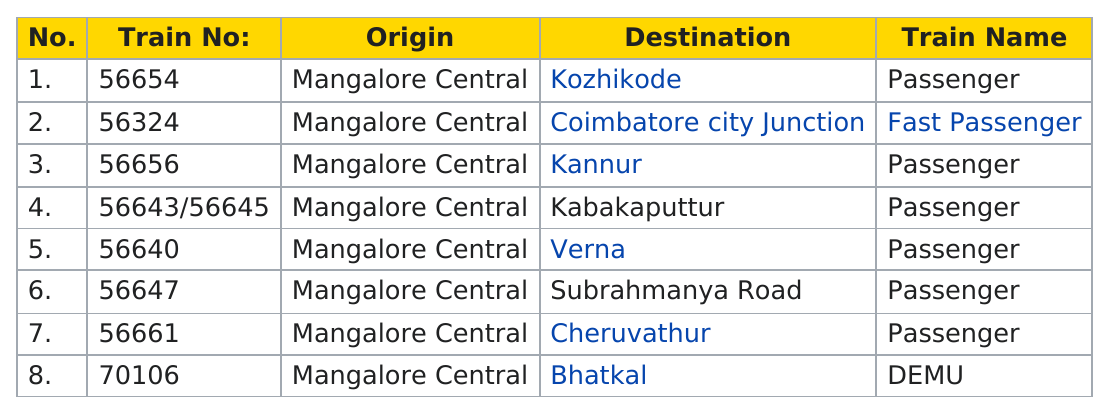Highlight a few significant elements in this photo. The next train number following 56661 is 70106. There are a total of 8 trains. How many DEMU trains are there in the category? The train number 56656 has its destination in Kannur. The first passenger train to leave Mangalore Central headed towards Kozhikode, marking the beginning of a new era of transportation in the region. 